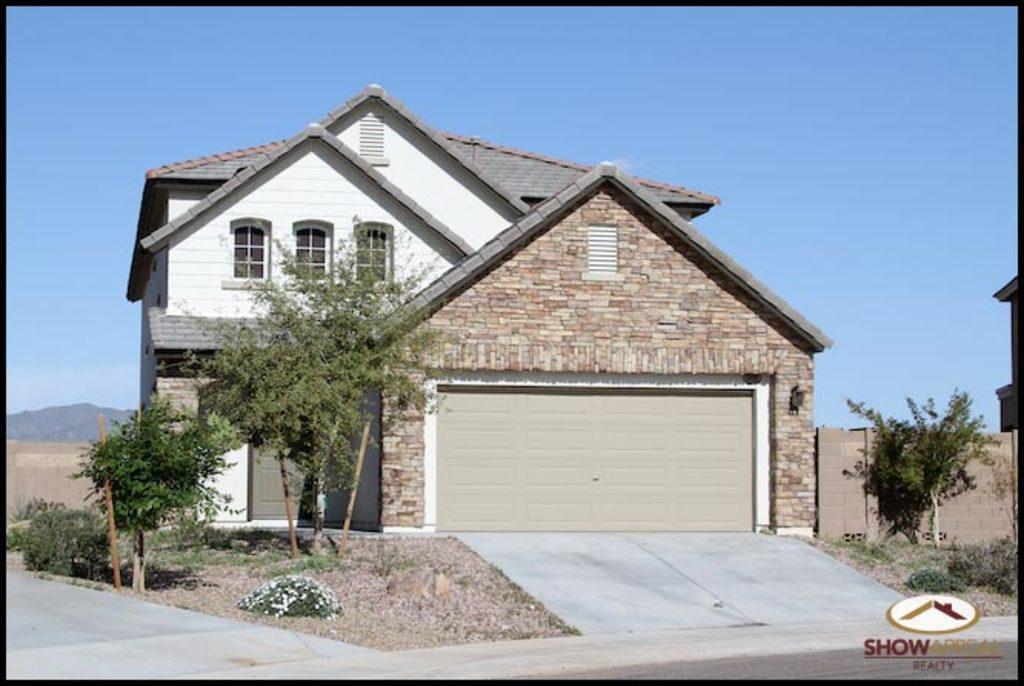Please provide a concise description of this image. In this image we can see a house, trees, road, plants and wooden boundary wall. In the background, we can see mountains and the sky. 